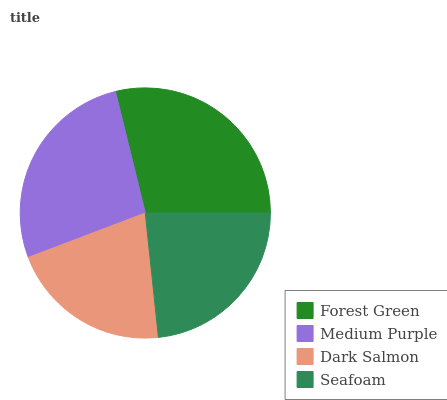Is Dark Salmon the minimum?
Answer yes or no. Yes. Is Forest Green the maximum?
Answer yes or no. Yes. Is Medium Purple the minimum?
Answer yes or no. No. Is Medium Purple the maximum?
Answer yes or no. No. Is Forest Green greater than Medium Purple?
Answer yes or no. Yes. Is Medium Purple less than Forest Green?
Answer yes or no. Yes. Is Medium Purple greater than Forest Green?
Answer yes or no. No. Is Forest Green less than Medium Purple?
Answer yes or no. No. Is Medium Purple the high median?
Answer yes or no. Yes. Is Seafoam the low median?
Answer yes or no. Yes. Is Forest Green the high median?
Answer yes or no. No. Is Forest Green the low median?
Answer yes or no. No. 